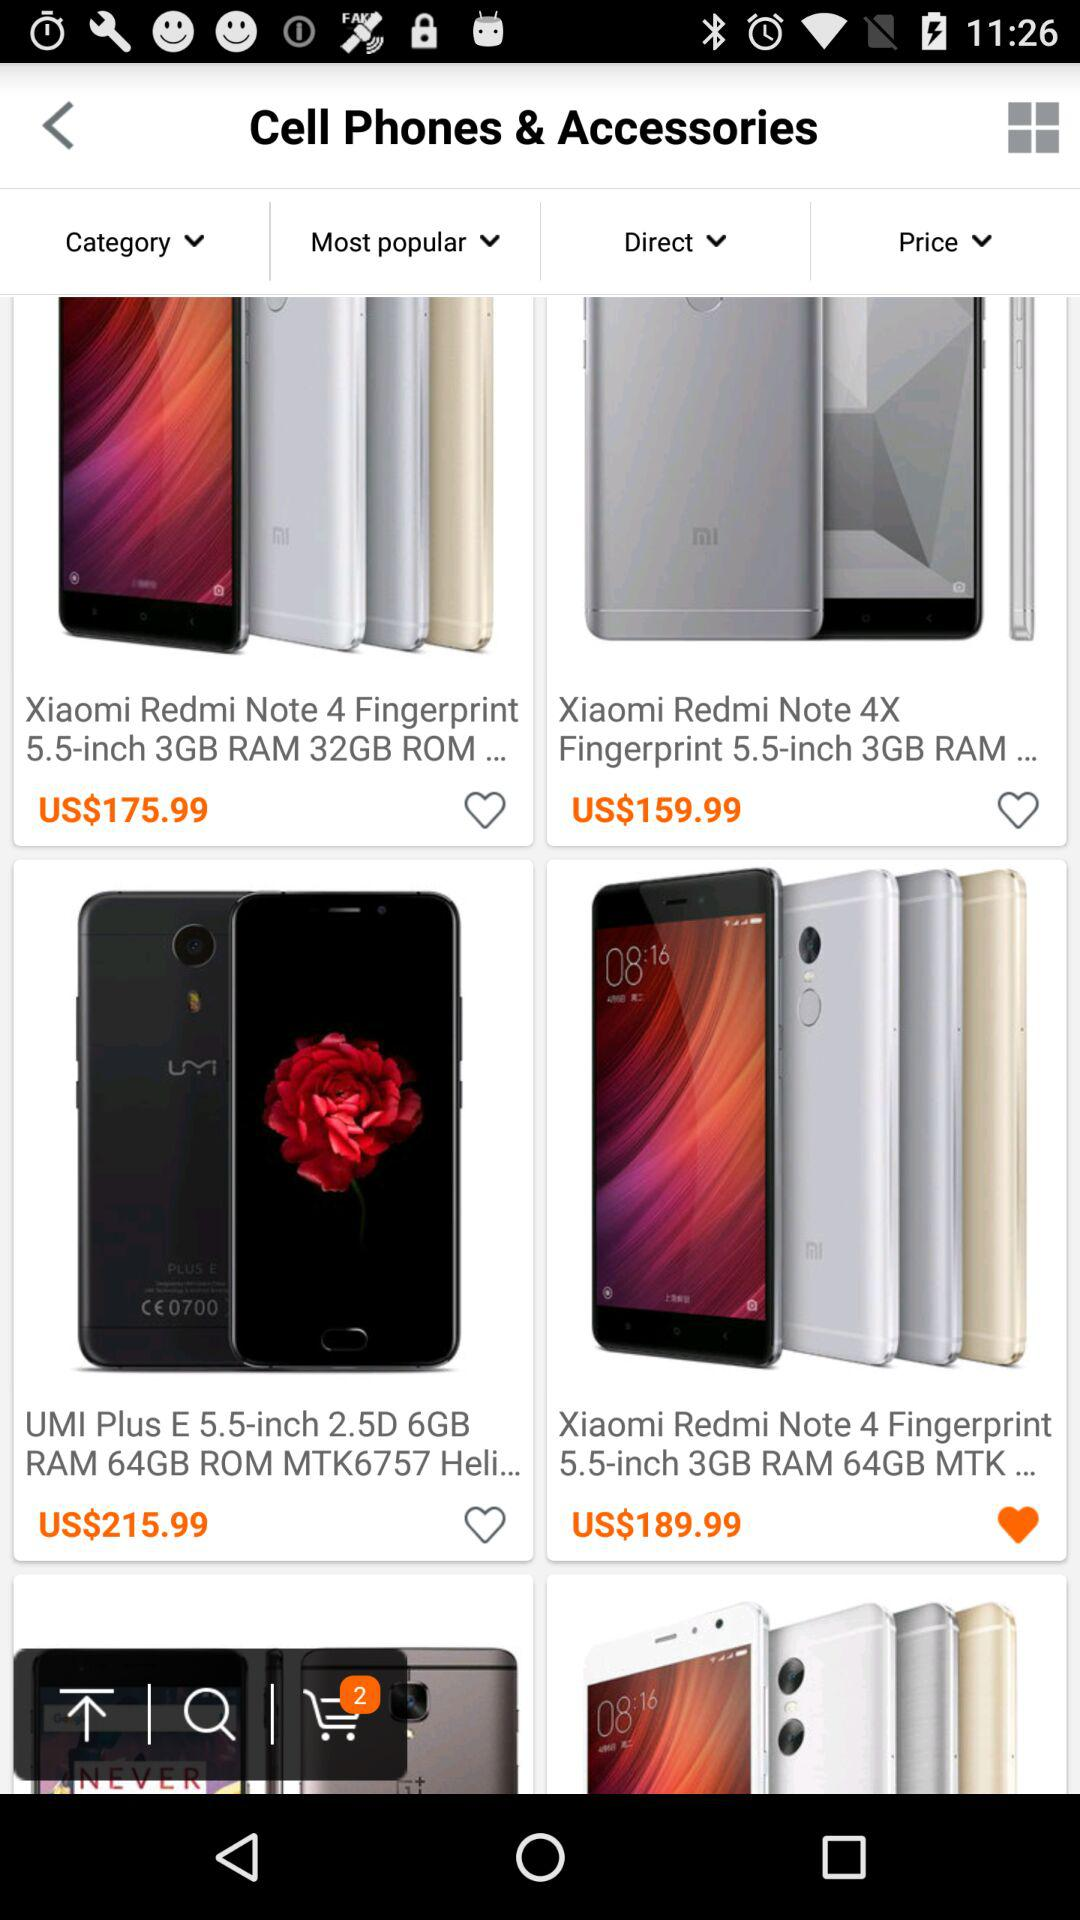How much does the "Xiaomi Redmi Note 4X Fingerprint 5.5-inch 3GB RAM" cost? The "Xiaomi Redmi Note 4X Fingerprint 5.5-inch 3GB RAM" costs US$159.99. 